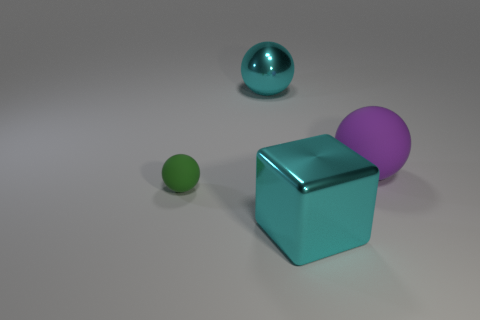Add 2 small red matte objects. How many objects exist? 6 Subtract all spheres. How many objects are left? 1 Subtract all yellow rubber objects. Subtract all big blocks. How many objects are left? 3 Add 1 metal objects. How many metal objects are left? 3 Add 3 small spheres. How many small spheres exist? 4 Subtract 0 purple cylinders. How many objects are left? 4 